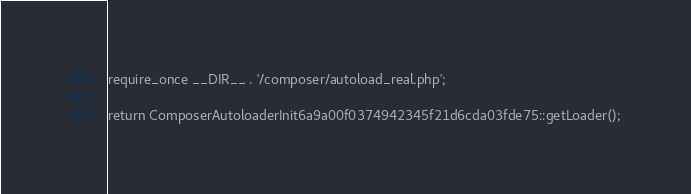Convert code to text. <code><loc_0><loc_0><loc_500><loc_500><_PHP_>
require_once __DIR__ . '/composer/autoload_real.php';

return ComposerAutoloaderInit6a9a00f0374942345f21d6cda03fde75::getLoader();
</code> 